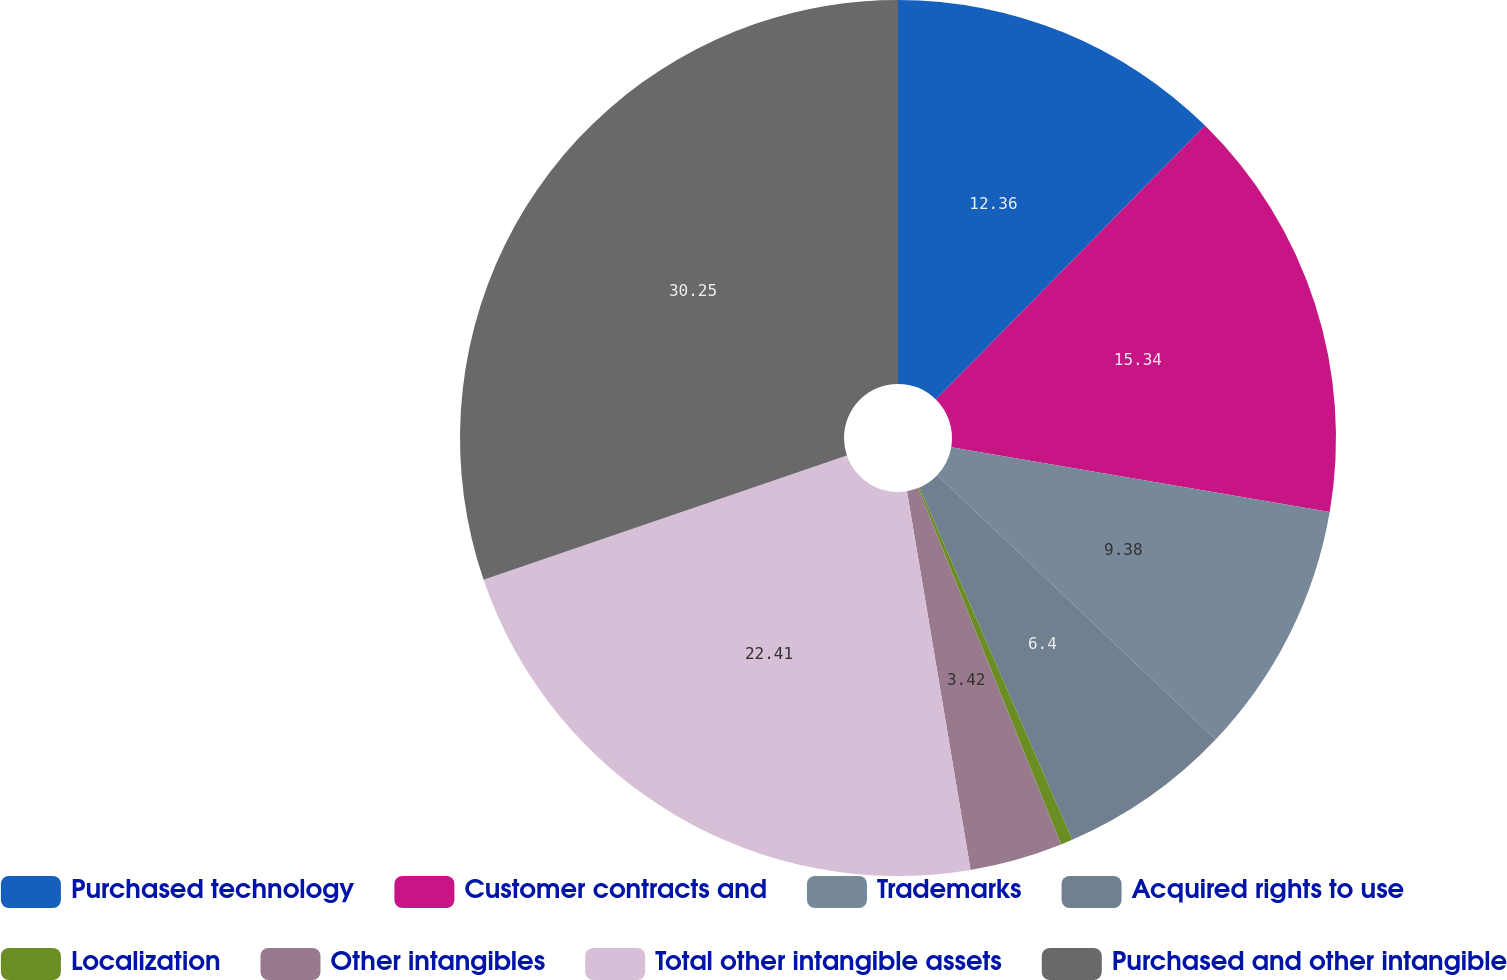<chart> <loc_0><loc_0><loc_500><loc_500><pie_chart><fcel>Purchased technology<fcel>Customer contracts and<fcel>Trademarks<fcel>Acquired rights to use<fcel>Localization<fcel>Other intangibles<fcel>Total other intangible assets<fcel>Purchased and other intangible<nl><fcel>12.36%<fcel>15.34%<fcel>9.38%<fcel>6.4%<fcel>0.44%<fcel>3.42%<fcel>22.4%<fcel>30.24%<nl></chart> 